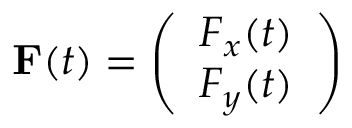<formula> <loc_0><loc_0><loc_500><loc_500>{ F } ( t ) = \left ( \begin{array} { l } { F _ { x } ( t ) } \\ { F _ { y } ( t ) } \end{array} \right )</formula> 